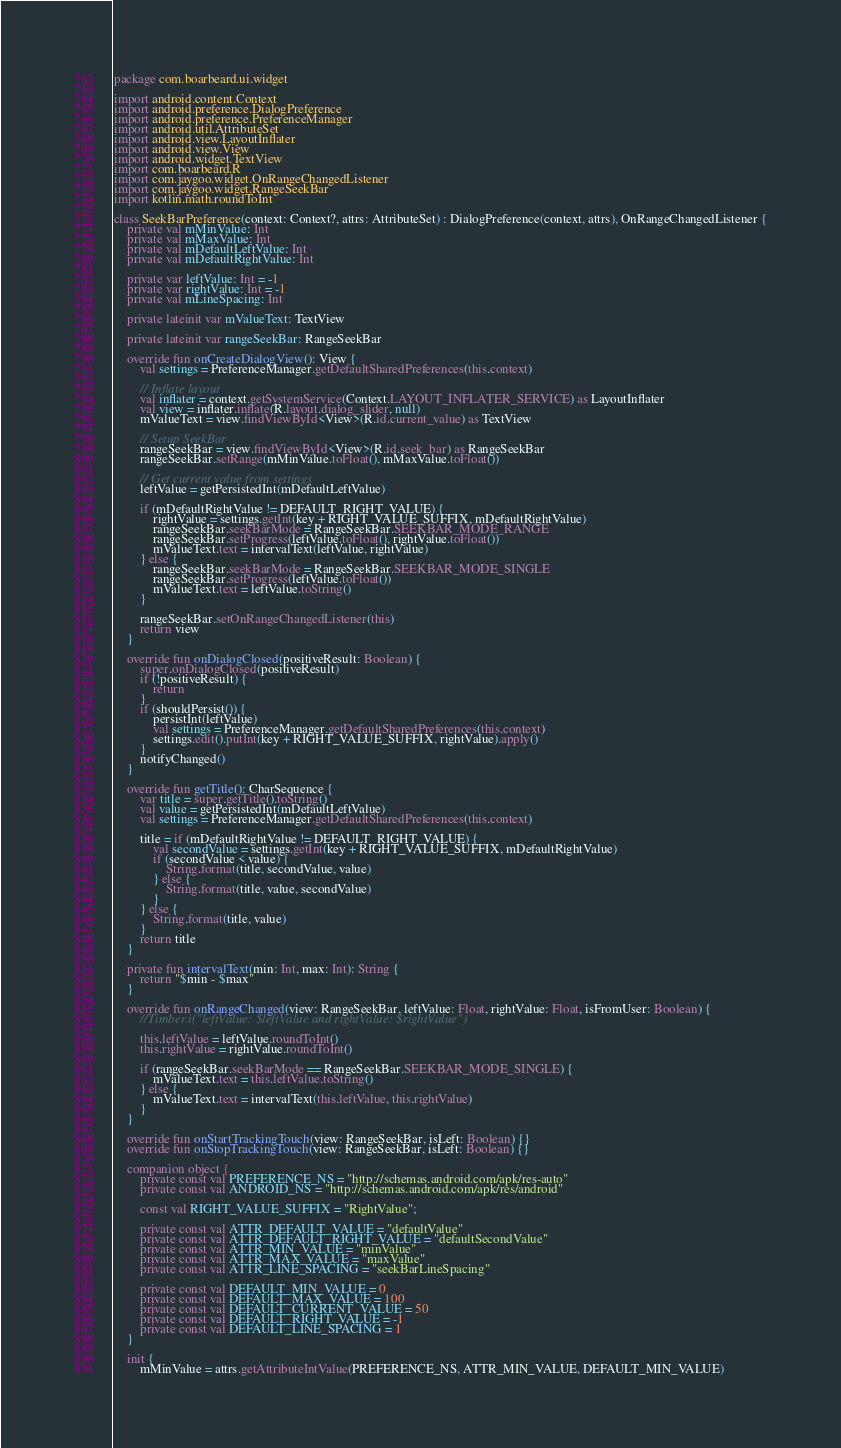<code> <loc_0><loc_0><loc_500><loc_500><_Kotlin_>package com.boarbeard.ui.widget

import android.content.Context
import android.preference.DialogPreference
import android.preference.PreferenceManager
import android.util.AttributeSet
import android.view.LayoutInflater
import android.view.View
import android.widget.TextView
import com.boarbeard.R
import com.jaygoo.widget.OnRangeChangedListener
import com.jaygoo.widget.RangeSeekBar
import kotlin.math.roundToInt

class SeekBarPreference(context: Context?, attrs: AttributeSet) : DialogPreference(context, attrs), OnRangeChangedListener {
    private val mMinValue: Int
    private val mMaxValue: Int
    private val mDefaultLeftValue: Int
    private val mDefaultRightValue: Int

    private var leftValue: Int = -1
    private var rightValue: Int = -1
    private val mLineSpacing: Int

    private lateinit var mValueText: TextView

    private lateinit var rangeSeekBar: RangeSeekBar

    override fun onCreateDialogView(): View {
        val settings = PreferenceManager.getDefaultSharedPreferences(this.context)

        // Inflate layout
        val inflater = context.getSystemService(Context.LAYOUT_INFLATER_SERVICE) as LayoutInflater
        val view = inflater.inflate(R.layout.dialog_slider, null)
        mValueText = view.findViewById<View>(R.id.current_value) as TextView

        // Setup SeekBar
        rangeSeekBar = view.findViewById<View>(R.id.seek_bar) as RangeSeekBar
        rangeSeekBar.setRange(mMinValue.toFloat(), mMaxValue.toFloat())

        // Get current value from settings
        leftValue = getPersistedInt(mDefaultLeftValue)

        if (mDefaultRightValue != DEFAULT_RIGHT_VALUE) {
            rightValue = settings.getInt(key + RIGHT_VALUE_SUFFIX, mDefaultRightValue)
            rangeSeekBar.seekBarMode = RangeSeekBar.SEEKBAR_MODE_RANGE
            rangeSeekBar.setProgress(leftValue.toFloat(), rightValue.toFloat())
            mValueText.text = intervalText(leftValue, rightValue)
        } else {
            rangeSeekBar.seekBarMode = RangeSeekBar.SEEKBAR_MODE_SINGLE
            rangeSeekBar.setProgress(leftValue.toFloat())
            mValueText.text = leftValue.toString()
        }

        rangeSeekBar.setOnRangeChangedListener(this)
        return view
    }

    override fun onDialogClosed(positiveResult: Boolean) {
        super.onDialogClosed(positiveResult)
        if (!positiveResult) {
            return
        }
        if (shouldPersist()) {
            persistInt(leftValue)
            val settings = PreferenceManager.getDefaultSharedPreferences(this.context)
            settings.edit().putInt(key + RIGHT_VALUE_SUFFIX, rightValue).apply()
        }
        notifyChanged()
    }

    override fun getTitle(): CharSequence {
        var title = super.getTitle().toString()
        val value = getPersistedInt(mDefaultLeftValue)
        val settings = PreferenceManager.getDefaultSharedPreferences(this.context)

        title = if (mDefaultRightValue != DEFAULT_RIGHT_VALUE) {
            val secondValue = settings.getInt(key + RIGHT_VALUE_SUFFIX, mDefaultRightValue)
            if (secondValue < value) {
                String.format(title, secondValue, value)
            } else {
                String.format(title, value, secondValue)
            }
        } else {
            String.format(title, value)
        }
        return title
    }

    private fun intervalText(min: Int, max: Int): String {
        return "$min - $max"
    }

    override fun onRangeChanged(view: RangeSeekBar, leftValue: Float, rightValue: Float, isFromUser: Boolean) {
        //Timber.i("leftValue: $leftValue and rightValue: $rightValue")

        this.leftValue = leftValue.roundToInt()
        this.rightValue = rightValue.roundToInt()

        if (rangeSeekBar.seekBarMode == RangeSeekBar.SEEKBAR_MODE_SINGLE) {
            mValueText.text = this.leftValue.toString()
        } else {
            mValueText.text = intervalText(this.leftValue, this.rightValue)
        }
    }

    override fun onStartTrackingTouch(view: RangeSeekBar, isLeft: Boolean) {}
    override fun onStopTrackingTouch(view: RangeSeekBar, isLeft: Boolean) {}

    companion object {
        private const val PREFERENCE_NS = "http://schemas.android.com/apk/res-auto"
        private const val ANDROID_NS = "http://schemas.android.com/apk/res/android"

        const val RIGHT_VALUE_SUFFIX = "RightValue";

        private const val ATTR_DEFAULT_VALUE = "defaultValue"
        private const val ATTR_DEFAULT_RIGHT_VALUE = "defaultSecondValue"
        private const val ATTR_MIN_VALUE = "minValue"
        private const val ATTR_MAX_VALUE = "maxValue"
        private const val ATTR_LINE_SPACING = "seekBarLineSpacing"

        private const val DEFAULT_MIN_VALUE = 0
        private const val DEFAULT_MAX_VALUE = 100
        private const val DEFAULT_CURRENT_VALUE = 50
        private const val DEFAULT_RIGHT_VALUE = -1
        private const val DEFAULT_LINE_SPACING = 1
    }

    init {
        mMinValue = attrs.getAttributeIntValue(PREFERENCE_NS, ATTR_MIN_VALUE, DEFAULT_MIN_VALUE)</code> 